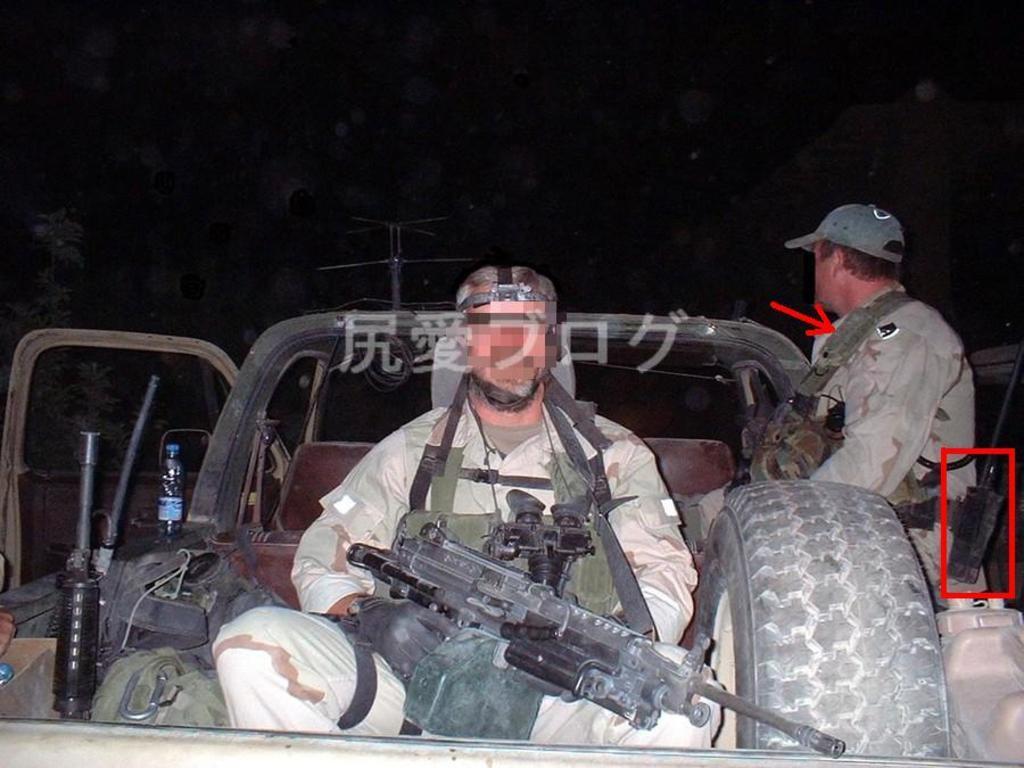In one or two sentences, can you explain what this image depicts? There are two people sitting in a vehicle and this person holding a gun,beside this person we can see tire. In the background we can see tree,pole and it is dark. 